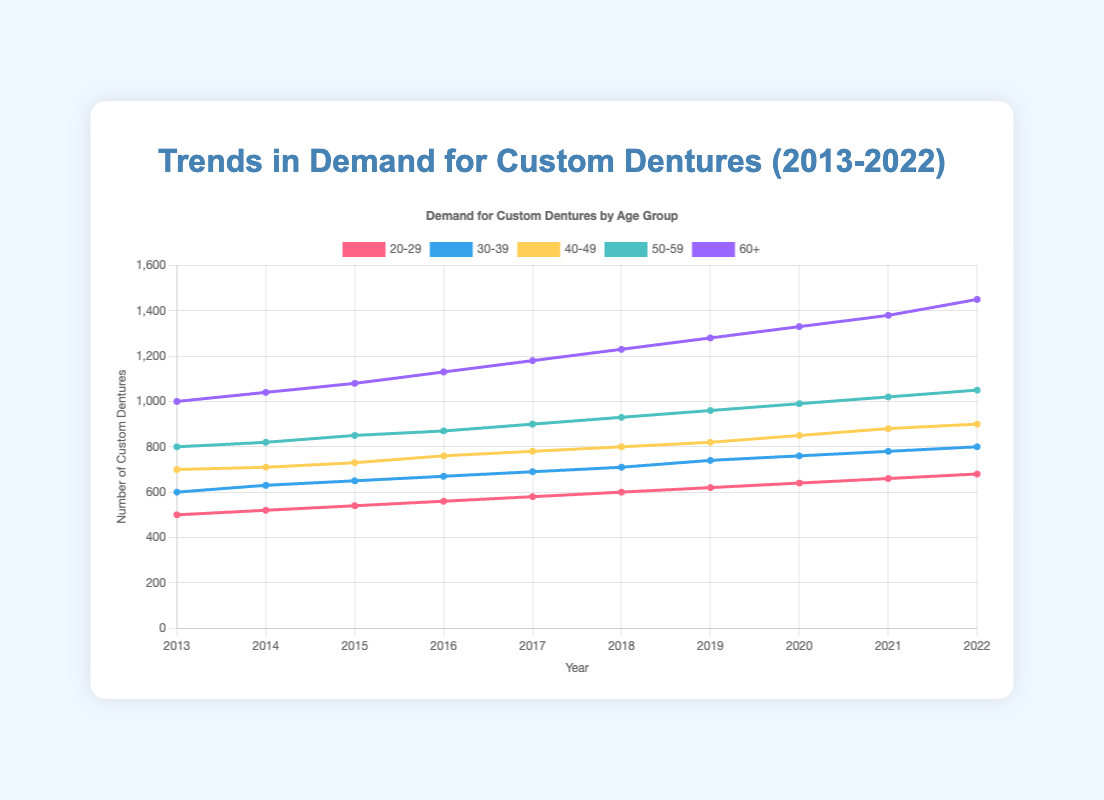What age group had the highest demand for custom dentures in 2022? Looking at the figure, the light-blue colored line representing the 60+ age group reaches the highest point in 2022.
Answer: 60+ How did the demand for the 20-29 age group change from 2013 to 2017? The pink-colored line for the 20-29 age group moves upward from 500 in 2013 to 580 in 2017. To see the difference, subtract the initial value from the final value (580 - 500).
Answer: Increased by 80 Which age group showed the highest increase in demand from 2013 to 2022? Checking the figure, the light-blue line for the 60+ age group rises noticeably more than any other line, from 1000 in 2013 to 1450 in 2022. The increase is calculated as 1450 - 1000.
Answer: 60+, increased by 450 By how much did the demand for the 50-59 age group grow between 2020 and 2021? The green-colored line for the 50-59 age group goes from 990 in 2020 to 1020 in 2021. The difference is 1020 - 990.
Answer: Increased by 30 What is the trend in demand for the 30-39 age group over the decade? Observing the blue-colored line for the 30-39 age group, it shows an upward trend overall, moving from 600 in 2013 to 800 in 2022.
Answer: Increasing trend 